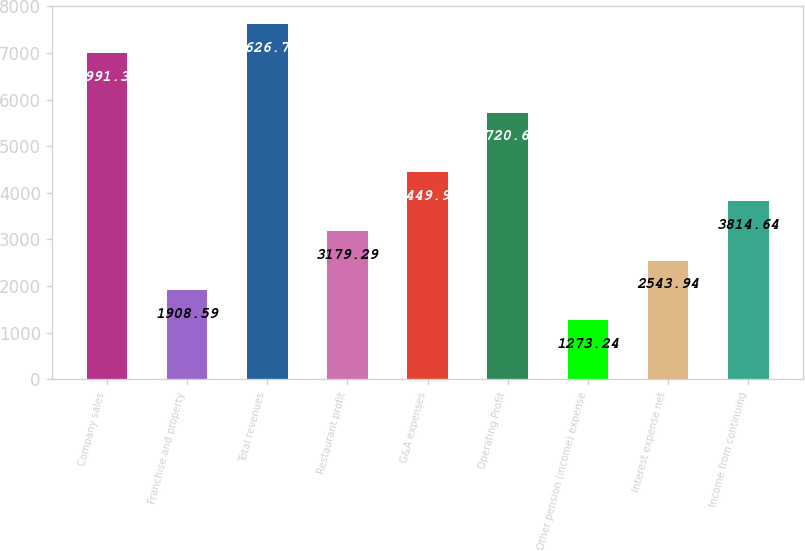<chart> <loc_0><loc_0><loc_500><loc_500><bar_chart><fcel>Company sales<fcel>Franchise and property<fcel>Total revenues<fcel>Restaurant profit<fcel>G&A expenses<fcel>Operating Profit<fcel>Other pension (income) expense<fcel>Interest expense net<fcel>Income from continuing<nl><fcel>6991.39<fcel>1908.59<fcel>7626.74<fcel>3179.29<fcel>4449.99<fcel>5720.69<fcel>1273.24<fcel>2543.94<fcel>3814.64<nl></chart> 